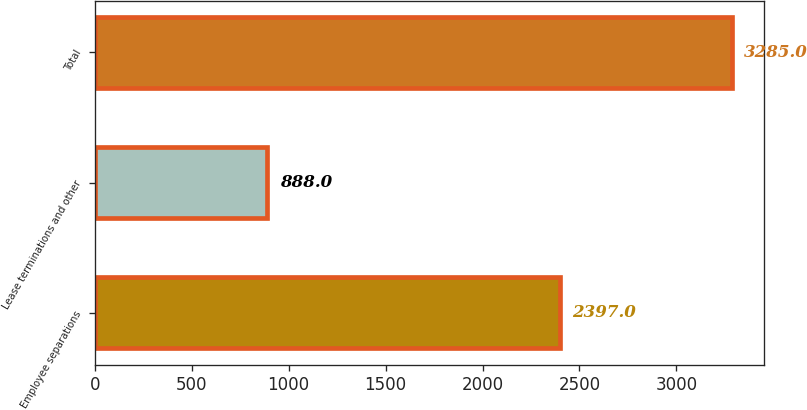<chart> <loc_0><loc_0><loc_500><loc_500><bar_chart><fcel>Employee separations<fcel>Lease terminations and other<fcel>Total<nl><fcel>2397<fcel>888<fcel>3285<nl></chart> 